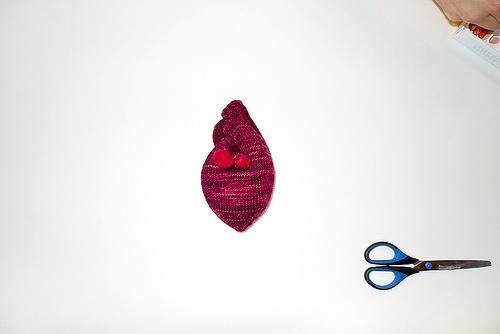What color is the scissors?
Give a very brief answer. Blue. What are the items sitting on?
Answer briefly. Table. What color is the item in the middle?
Concise answer only. Red. 